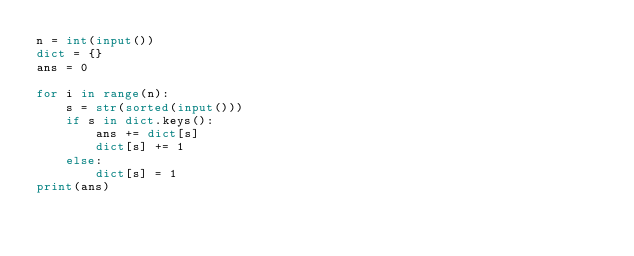<code> <loc_0><loc_0><loc_500><loc_500><_Python_>n = int(input())
dict = {}
ans = 0

for i in range(n):
    s = str(sorted(input()))
    if s in dict.keys():
        ans += dict[s]
        dict[s] += 1
    else:
        dict[s] = 1
print(ans)
</code> 